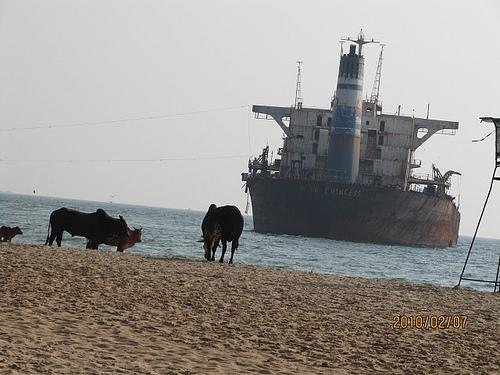How many cows are sniffing around on the beach front?

Choices:
A) two
B) three
C) one
D) four four 